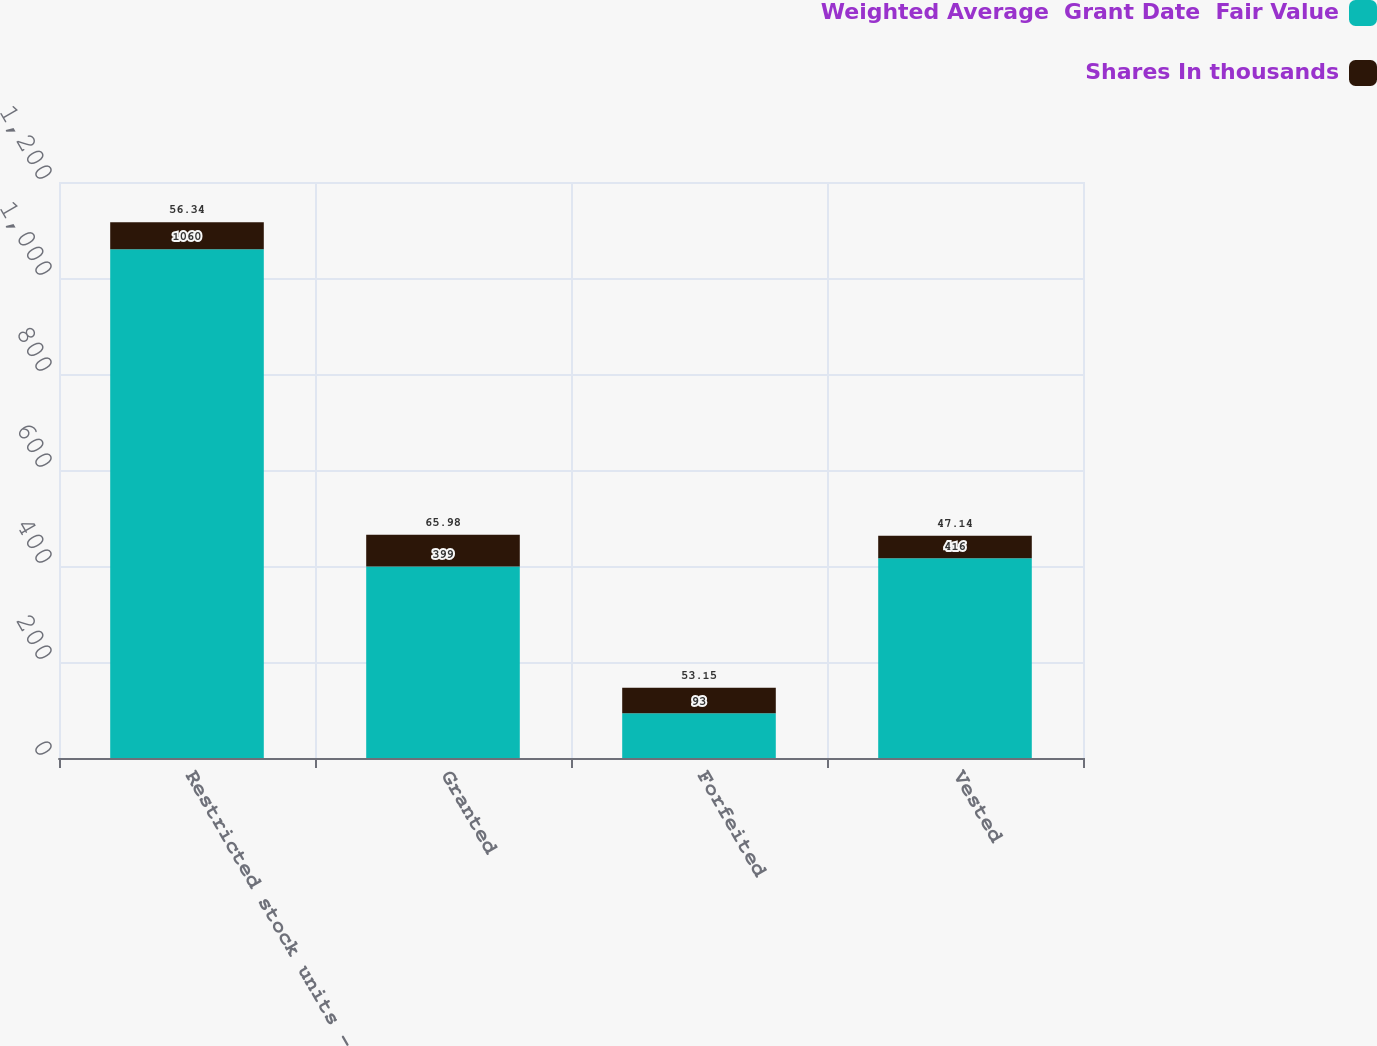Convert chart. <chart><loc_0><loc_0><loc_500><loc_500><stacked_bar_chart><ecel><fcel>Restricted stock units -<fcel>Granted<fcel>Forfeited<fcel>Vested<nl><fcel>Weighted Average  Grant Date  Fair Value<fcel>1060<fcel>399<fcel>93<fcel>416<nl><fcel>Shares In thousands<fcel>56.34<fcel>65.98<fcel>53.15<fcel>47.14<nl></chart> 